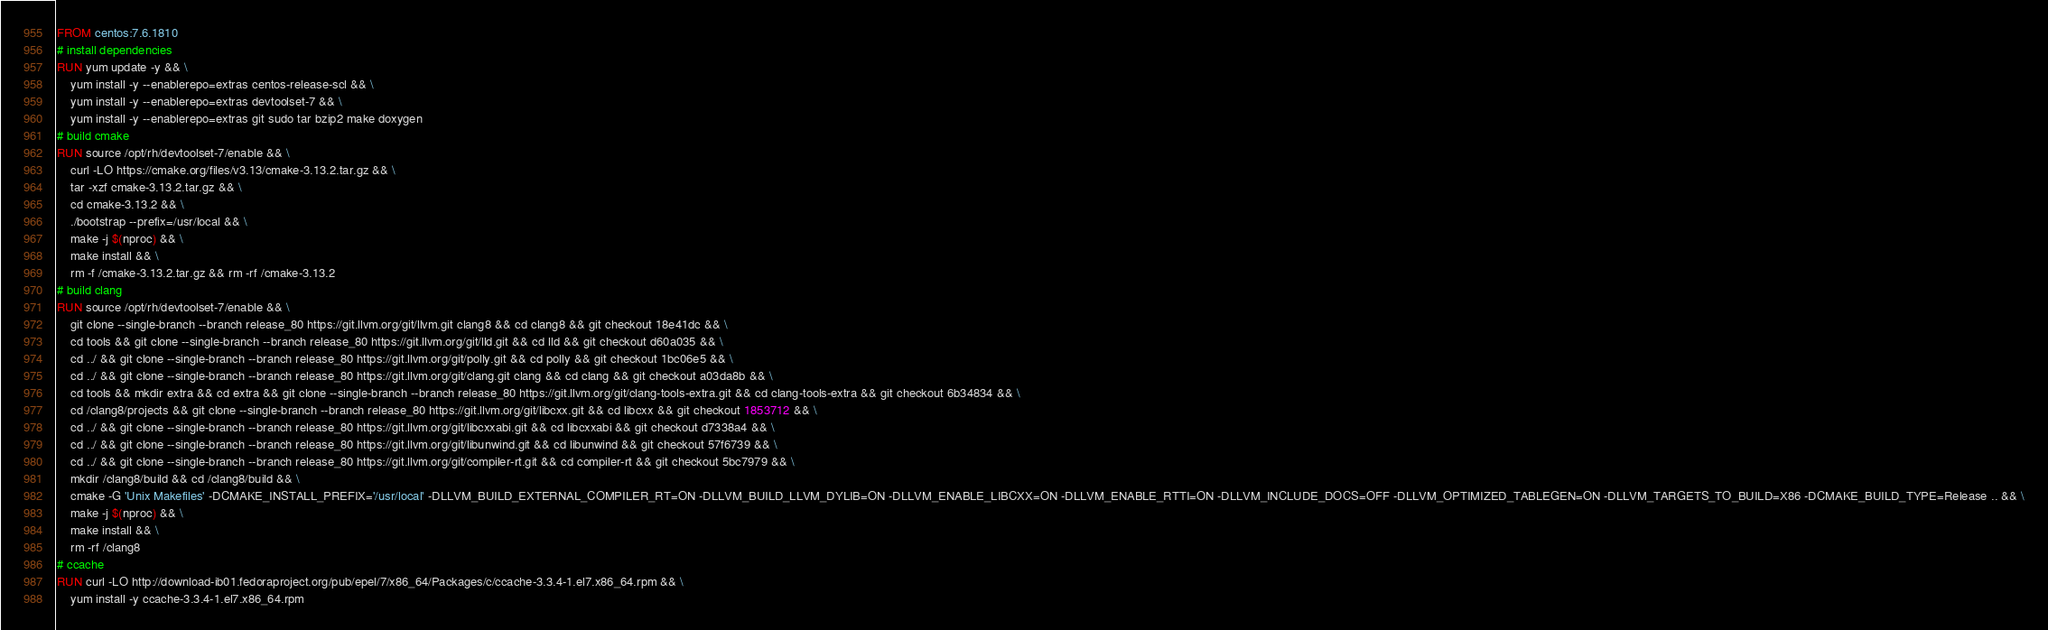Convert code to text. <code><loc_0><loc_0><loc_500><loc_500><_Dockerfile_>FROM centos:7.6.1810
# install dependencies
RUN yum update -y && \
    yum install -y --enablerepo=extras centos-release-scl && \
    yum install -y --enablerepo=extras devtoolset-7 && \
    yum install -y --enablerepo=extras git sudo tar bzip2 make doxygen
# build cmake
RUN source /opt/rh/devtoolset-7/enable && \
    curl -LO https://cmake.org/files/v3.13/cmake-3.13.2.tar.gz && \
    tar -xzf cmake-3.13.2.tar.gz && \
    cd cmake-3.13.2 && \
    ./bootstrap --prefix=/usr/local && \
    make -j $(nproc) && \
    make install && \
    rm -f /cmake-3.13.2.tar.gz && rm -rf /cmake-3.13.2
# build clang
RUN source /opt/rh/devtoolset-7/enable && \
    git clone --single-branch --branch release_80 https://git.llvm.org/git/llvm.git clang8 && cd clang8 && git checkout 18e41dc && \
    cd tools && git clone --single-branch --branch release_80 https://git.llvm.org/git/lld.git && cd lld && git checkout d60a035 && \
    cd ../ && git clone --single-branch --branch release_80 https://git.llvm.org/git/polly.git && cd polly && git checkout 1bc06e5 && \
    cd ../ && git clone --single-branch --branch release_80 https://git.llvm.org/git/clang.git clang && cd clang && git checkout a03da8b && \
    cd tools && mkdir extra && cd extra && git clone --single-branch --branch release_80 https://git.llvm.org/git/clang-tools-extra.git && cd clang-tools-extra && git checkout 6b34834 && \
    cd /clang8/projects && git clone --single-branch --branch release_80 https://git.llvm.org/git/libcxx.git && cd libcxx && git checkout 1853712 && \
    cd ../ && git clone --single-branch --branch release_80 https://git.llvm.org/git/libcxxabi.git && cd libcxxabi && git checkout d7338a4 && \
    cd ../ && git clone --single-branch --branch release_80 https://git.llvm.org/git/libunwind.git && cd libunwind && git checkout 57f6739 && \
    cd ../ && git clone --single-branch --branch release_80 https://git.llvm.org/git/compiler-rt.git && cd compiler-rt && git checkout 5bc7979 && \
    mkdir /clang8/build && cd /clang8/build && \
    cmake -G 'Unix Makefiles' -DCMAKE_INSTALL_PREFIX='/usr/local' -DLLVM_BUILD_EXTERNAL_COMPILER_RT=ON -DLLVM_BUILD_LLVM_DYLIB=ON -DLLVM_ENABLE_LIBCXX=ON -DLLVM_ENABLE_RTTI=ON -DLLVM_INCLUDE_DOCS=OFF -DLLVM_OPTIMIZED_TABLEGEN=ON -DLLVM_TARGETS_TO_BUILD=X86 -DCMAKE_BUILD_TYPE=Release .. && \
    make -j $(nproc) && \
    make install && \
    rm -rf /clang8
# ccache
RUN curl -LO http://download-ib01.fedoraproject.org/pub/epel/7/x86_64/Packages/c/ccache-3.3.4-1.el7.x86_64.rpm && \
    yum install -y ccache-3.3.4-1.el7.x86_64.rpm</code> 